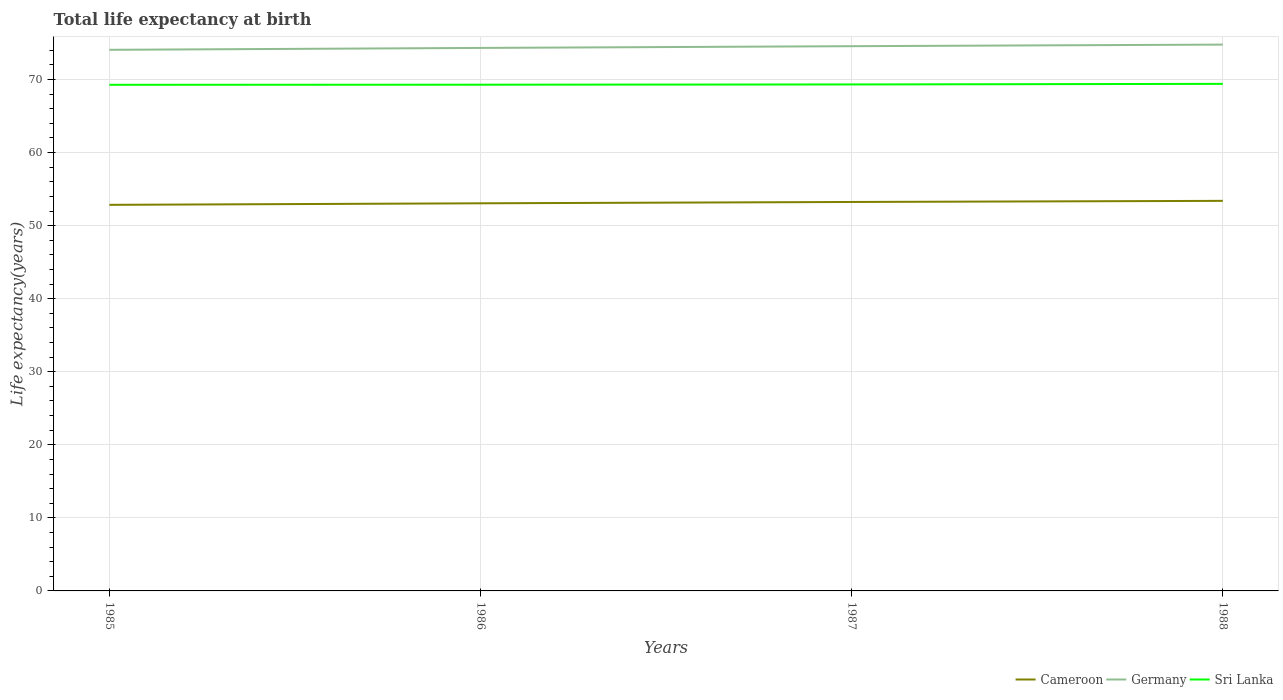Across all years, what is the maximum life expectancy at birth in in Germany?
Offer a terse response. 74.06. In which year was the life expectancy at birth in in Cameroon maximum?
Your answer should be very brief. 1985. What is the total life expectancy at birth in in Cameroon in the graph?
Give a very brief answer. -0.39. What is the difference between the highest and the second highest life expectancy at birth in in Cameroon?
Your answer should be very brief. 0.55. What is the difference between the highest and the lowest life expectancy at birth in in Sri Lanka?
Your response must be concise. 1. Is the life expectancy at birth in in Cameroon strictly greater than the life expectancy at birth in in Germany over the years?
Make the answer very short. Yes. How many years are there in the graph?
Keep it short and to the point. 4. What is the difference between two consecutive major ticks on the Y-axis?
Your response must be concise. 10. Where does the legend appear in the graph?
Provide a succinct answer. Bottom right. What is the title of the graph?
Provide a succinct answer. Total life expectancy at birth. What is the label or title of the Y-axis?
Provide a short and direct response. Life expectancy(years). What is the Life expectancy(years) of Cameroon in 1985?
Give a very brief answer. 52.84. What is the Life expectancy(years) of Germany in 1985?
Keep it short and to the point. 74.06. What is the Life expectancy(years) in Sri Lanka in 1985?
Provide a short and direct response. 69.28. What is the Life expectancy(years) of Cameroon in 1986?
Give a very brief answer. 53.06. What is the Life expectancy(years) in Germany in 1986?
Make the answer very short. 74.32. What is the Life expectancy(years) of Sri Lanka in 1986?
Provide a succinct answer. 69.29. What is the Life expectancy(years) in Cameroon in 1987?
Offer a terse response. 53.24. What is the Life expectancy(years) in Germany in 1987?
Offer a terse response. 74.56. What is the Life expectancy(years) in Sri Lanka in 1987?
Provide a short and direct response. 69.32. What is the Life expectancy(years) of Cameroon in 1988?
Keep it short and to the point. 53.39. What is the Life expectancy(years) of Germany in 1988?
Ensure brevity in your answer.  74.78. What is the Life expectancy(years) of Sri Lanka in 1988?
Keep it short and to the point. 69.4. Across all years, what is the maximum Life expectancy(years) in Cameroon?
Your answer should be very brief. 53.39. Across all years, what is the maximum Life expectancy(years) of Germany?
Provide a succinct answer. 74.78. Across all years, what is the maximum Life expectancy(years) in Sri Lanka?
Ensure brevity in your answer.  69.4. Across all years, what is the minimum Life expectancy(years) in Cameroon?
Ensure brevity in your answer.  52.84. Across all years, what is the minimum Life expectancy(years) of Germany?
Offer a terse response. 74.06. Across all years, what is the minimum Life expectancy(years) of Sri Lanka?
Provide a succinct answer. 69.28. What is the total Life expectancy(years) in Cameroon in the graph?
Your answer should be very brief. 212.53. What is the total Life expectancy(years) in Germany in the graph?
Ensure brevity in your answer.  297.72. What is the total Life expectancy(years) in Sri Lanka in the graph?
Keep it short and to the point. 277.29. What is the difference between the Life expectancy(years) in Cameroon in 1985 and that in 1986?
Give a very brief answer. -0.21. What is the difference between the Life expectancy(years) in Germany in 1985 and that in 1986?
Provide a short and direct response. -0.26. What is the difference between the Life expectancy(years) of Sri Lanka in 1985 and that in 1986?
Make the answer very short. -0.01. What is the difference between the Life expectancy(years) in Cameroon in 1985 and that in 1987?
Your answer should be very brief. -0.39. What is the difference between the Life expectancy(years) in Germany in 1985 and that in 1987?
Your answer should be compact. -0.5. What is the difference between the Life expectancy(years) of Sri Lanka in 1985 and that in 1987?
Your answer should be very brief. -0.05. What is the difference between the Life expectancy(years) of Cameroon in 1985 and that in 1988?
Make the answer very short. -0.55. What is the difference between the Life expectancy(years) of Germany in 1985 and that in 1988?
Ensure brevity in your answer.  -0.71. What is the difference between the Life expectancy(years) in Sri Lanka in 1985 and that in 1988?
Ensure brevity in your answer.  -0.13. What is the difference between the Life expectancy(years) of Cameroon in 1986 and that in 1987?
Your answer should be very brief. -0.18. What is the difference between the Life expectancy(years) of Germany in 1986 and that in 1987?
Keep it short and to the point. -0.24. What is the difference between the Life expectancy(years) of Sri Lanka in 1986 and that in 1987?
Ensure brevity in your answer.  -0.03. What is the difference between the Life expectancy(years) of Cameroon in 1986 and that in 1988?
Provide a short and direct response. -0.33. What is the difference between the Life expectancy(years) of Germany in 1986 and that in 1988?
Provide a succinct answer. -0.46. What is the difference between the Life expectancy(years) in Sri Lanka in 1986 and that in 1988?
Your answer should be compact. -0.12. What is the difference between the Life expectancy(years) of Cameroon in 1987 and that in 1988?
Provide a short and direct response. -0.15. What is the difference between the Life expectancy(years) in Germany in 1987 and that in 1988?
Ensure brevity in your answer.  -0.22. What is the difference between the Life expectancy(years) of Sri Lanka in 1987 and that in 1988?
Make the answer very short. -0.08. What is the difference between the Life expectancy(years) in Cameroon in 1985 and the Life expectancy(years) in Germany in 1986?
Your response must be concise. -21.48. What is the difference between the Life expectancy(years) in Cameroon in 1985 and the Life expectancy(years) in Sri Lanka in 1986?
Your response must be concise. -16.44. What is the difference between the Life expectancy(years) in Germany in 1985 and the Life expectancy(years) in Sri Lanka in 1986?
Make the answer very short. 4.78. What is the difference between the Life expectancy(years) of Cameroon in 1985 and the Life expectancy(years) of Germany in 1987?
Your response must be concise. -21.71. What is the difference between the Life expectancy(years) in Cameroon in 1985 and the Life expectancy(years) in Sri Lanka in 1987?
Offer a terse response. -16.48. What is the difference between the Life expectancy(years) in Germany in 1985 and the Life expectancy(years) in Sri Lanka in 1987?
Ensure brevity in your answer.  4.74. What is the difference between the Life expectancy(years) of Cameroon in 1985 and the Life expectancy(years) of Germany in 1988?
Offer a very short reply. -21.93. What is the difference between the Life expectancy(years) of Cameroon in 1985 and the Life expectancy(years) of Sri Lanka in 1988?
Provide a succinct answer. -16.56. What is the difference between the Life expectancy(years) of Germany in 1985 and the Life expectancy(years) of Sri Lanka in 1988?
Provide a short and direct response. 4.66. What is the difference between the Life expectancy(years) in Cameroon in 1986 and the Life expectancy(years) in Germany in 1987?
Offer a terse response. -21.5. What is the difference between the Life expectancy(years) of Cameroon in 1986 and the Life expectancy(years) of Sri Lanka in 1987?
Your answer should be very brief. -16.27. What is the difference between the Life expectancy(years) of Germany in 1986 and the Life expectancy(years) of Sri Lanka in 1987?
Offer a terse response. 5. What is the difference between the Life expectancy(years) in Cameroon in 1986 and the Life expectancy(years) in Germany in 1988?
Provide a succinct answer. -21.72. What is the difference between the Life expectancy(years) in Cameroon in 1986 and the Life expectancy(years) in Sri Lanka in 1988?
Keep it short and to the point. -16.35. What is the difference between the Life expectancy(years) of Germany in 1986 and the Life expectancy(years) of Sri Lanka in 1988?
Ensure brevity in your answer.  4.92. What is the difference between the Life expectancy(years) in Cameroon in 1987 and the Life expectancy(years) in Germany in 1988?
Keep it short and to the point. -21.54. What is the difference between the Life expectancy(years) in Cameroon in 1987 and the Life expectancy(years) in Sri Lanka in 1988?
Your answer should be very brief. -16.16. What is the difference between the Life expectancy(years) of Germany in 1987 and the Life expectancy(years) of Sri Lanka in 1988?
Make the answer very short. 5.16. What is the average Life expectancy(years) in Cameroon per year?
Give a very brief answer. 53.13. What is the average Life expectancy(years) in Germany per year?
Ensure brevity in your answer.  74.43. What is the average Life expectancy(years) in Sri Lanka per year?
Offer a terse response. 69.32. In the year 1985, what is the difference between the Life expectancy(years) in Cameroon and Life expectancy(years) in Germany?
Make the answer very short. -21.22. In the year 1985, what is the difference between the Life expectancy(years) of Cameroon and Life expectancy(years) of Sri Lanka?
Your response must be concise. -16.43. In the year 1985, what is the difference between the Life expectancy(years) in Germany and Life expectancy(years) in Sri Lanka?
Offer a very short reply. 4.79. In the year 1986, what is the difference between the Life expectancy(years) in Cameroon and Life expectancy(years) in Germany?
Provide a short and direct response. -21.26. In the year 1986, what is the difference between the Life expectancy(years) of Cameroon and Life expectancy(years) of Sri Lanka?
Offer a very short reply. -16.23. In the year 1986, what is the difference between the Life expectancy(years) in Germany and Life expectancy(years) in Sri Lanka?
Give a very brief answer. 5.03. In the year 1987, what is the difference between the Life expectancy(years) of Cameroon and Life expectancy(years) of Germany?
Your answer should be compact. -21.32. In the year 1987, what is the difference between the Life expectancy(years) of Cameroon and Life expectancy(years) of Sri Lanka?
Offer a terse response. -16.08. In the year 1987, what is the difference between the Life expectancy(years) of Germany and Life expectancy(years) of Sri Lanka?
Ensure brevity in your answer.  5.24. In the year 1988, what is the difference between the Life expectancy(years) in Cameroon and Life expectancy(years) in Germany?
Provide a succinct answer. -21.39. In the year 1988, what is the difference between the Life expectancy(years) in Cameroon and Life expectancy(years) in Sri Lanka?
Your response must be concise. -16.01. In the year 1988, what is the difference between the Life expectancy(years) of Germany and Life expectancy(years) of Sri Lanka?
Offer a very short reply. 5.38. What is the ratio of the Life expectancy(years) in Cameroon in 1985 to that in 1986?
Keep it short and to the point. 1. What is the ratio of the Life expectancy(years) in Germany in 1985 to that in 1986?
Your response must be concise. 1. What is the ratio of the Life expectancy(years) in Germany in 1985 to that in 1987?
Keep it short and to the point. 0.99. What is the ratio of the Life expectancy(years) in Germany in 1985 to that in 1988?
Provide a succinct answer. 0.99. What is the ratio of the Life expectancy(years) in Sri Lanka in 1985 to that in 1988?
Offer a very short reply. 1. What is the ratio of the Life expectancy(years) in Cameroon in 1986 to that in 1987?
Offer a terse response. 1. What is the ratio of the Life expectancy(years) of Germany in 1986 to that in 1987?
Your answer should be very brief. 1. What is the ratio of the Life expectancy(years) of Sri Lanka in 1986 to that in 1987?
Keep it short and to the point. 1. What is the ratio of the Life expectancy(years) in Cameroon in 1986 to that in 1988?
Keep it short and to the point. 0.99. What is the ratio of the Life expectancy(years) in Germany in 1986 to that in 1988?
Provide a short and direct response. 0.99. What is the ratio of the Life expectancy(years) in Cameroon in 1987 to that in 1988?
Give a very brief answer. 1. What is the ratio of the Life expectancy(years) of Sri Lanka in 1987 to that in 1988?
Offer a very short reply. 1. What is the difference between the highest and the second highest Life expectancy(years) in Cameroon?
Make the answer very short. 0.15. What is the difference between the highest and the second highest Life expectancy(years) in Germany?
Your response must be concise. 0.22. What is the difference between the highest and the second highest Life expectancy(years) in Sri Lanka?
Your answer should be very brief. 0.08. What is the difference between the highest and the lowest Life expectancy(years) in Cameroon?
Give a very brief answer. 0.55. What is the difference between the highest and the lowest Life expectancy(years) of Germany?
Offer a very short reply. 0.71. What is the difference between the highest and the lowest Life expectancy(years) of Sri Lanka?
Provide a short and direct response. 0.13. 